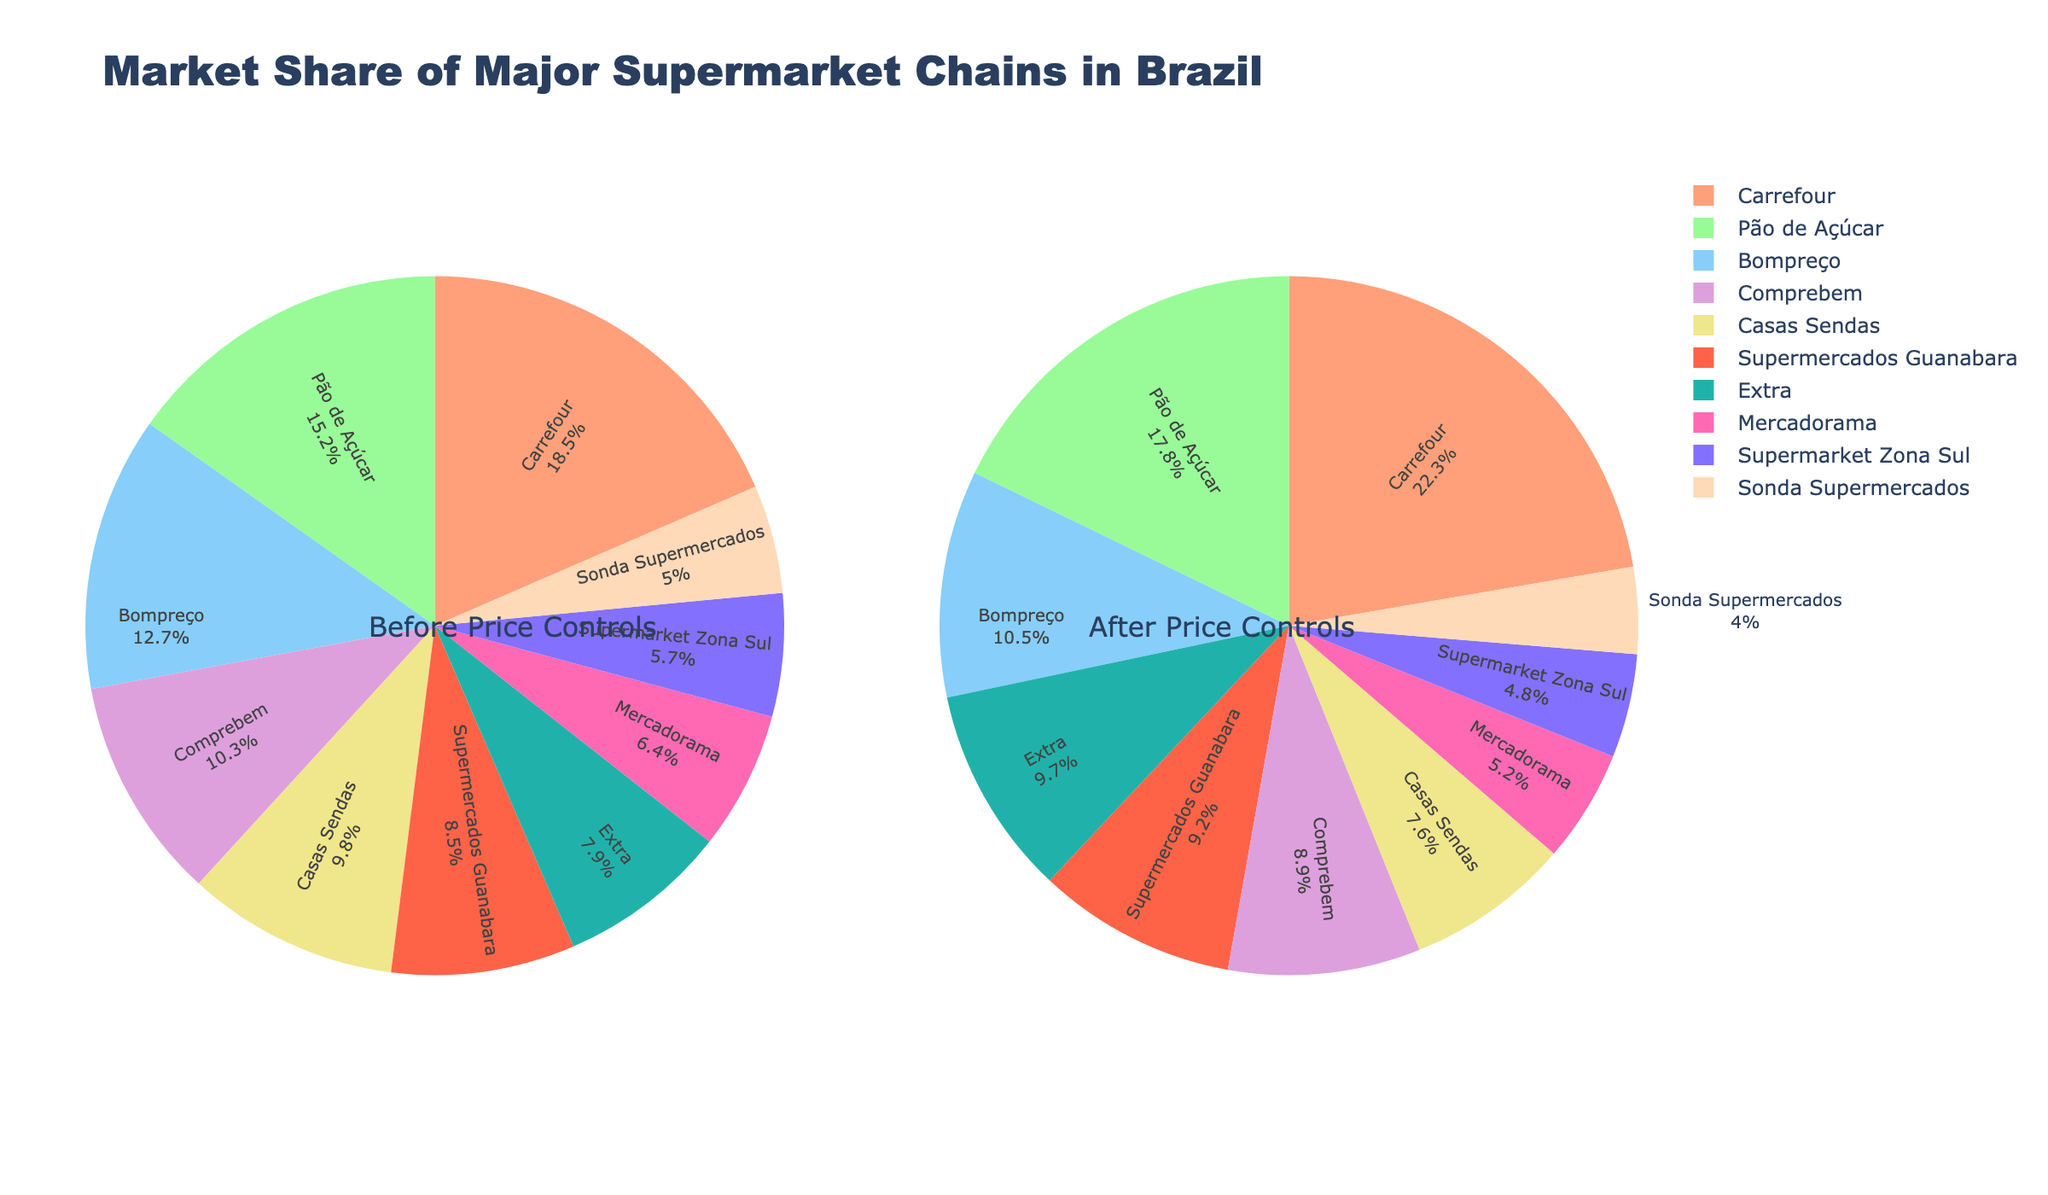Which supermarket chain had the largest increase in market share after the price controls? Compare the percentage points from "After Price Controls" with "Before Price Controls" for all chains and find the one with the largest positive difference. Carrefour increased from 18.5% to 22.3%, a difference of 3.8%. This is the largest increase.
Answer: Carrefour Which supermarket chain’s market share decreased the most after the price controls? Compare the percentage points from "After Price Controls" with "Before Price Controls" for all chains and find the one with the largest negative difference. Casas Sendas dropped from 9.8% to 7.6%, a difference of -2.2%. This is the largest decrease.
Answer: Casas Sendas What is the combined market share of Pão de Açúcar and Extra after the price controls? Add the percentages of Pão de Açúcar (17.8%) and Extra (9.7%) from "After Price Controls". The combined market share is 17.8% + 9.7% = 27.5%.
Answer: 27.5% Which supermarket chain had a higher market share before the price controls: Mercadorama or Sonda Supermercados? Compare the percentages of Mercadorama and Sonda Supermercados from "Before Price Controls". Mercadorama had 6.4% while Sonda Supermercados had 5.0%. Therefore, Mercadorama had a higher market share.
Answer: Mercadorama How many supermarket chains had a market share greater than 10% after the price controls? Count the number of chains with percentages greater than 10% from "After Price Controls". Carrefour (22.3%), Pão de Açúcar (17.8%), and Extra (9.7%)—only Carrefour and Pão de Açúcar exceed 10%.
Answer: 2 What is the average market share of all supermarket chains before the price controls? Calculate the average by summing all percentages from "Before Price Controls" and dividing by the number of chains. The sum is 18.5 + 15.2 + 12.7 + 10.3 + 9.8 + 8.5 + 7.9 + 6.4 + 5.7 + 5.0 = 100.0%. The average is 100.0% / 10 = 10%.
Answer: 10% Which chain had a smaller market share after the price controls compared to before, but still retained popular market presence? Identify chains that decreased their market share after the price controls but still had a significant share. Bompreço dropped from 12.7% to 10.5% but still had a notable 10.5% share.
Answer: Bompreço Which chain maintained the closest to an equal market share before and after the price controls? Calculate the absolute difference for each chain between "Before Price Controls" and "After Price Controls". Supermarket Zona Sul went from 5.7% to 4.8%, a difference of 0.9%, the smallest among all chains.
Answer: Supermarket Zona Sul 